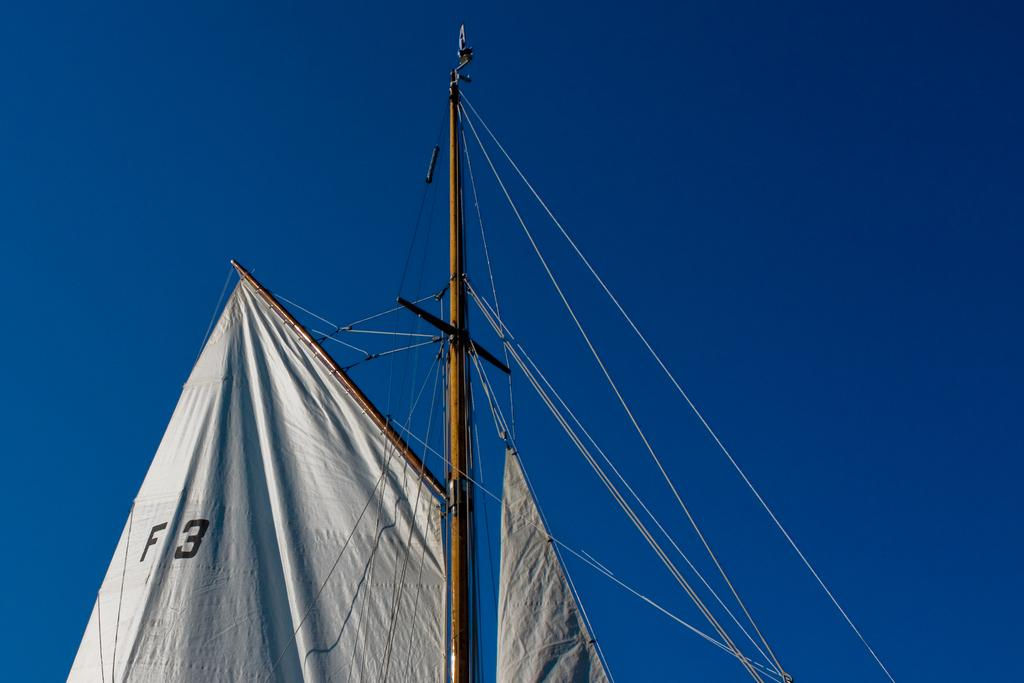<image>
Offer a succinct explanation of the picture presented. Top of a ship that says F3 on it with strings attached to the top pole. 